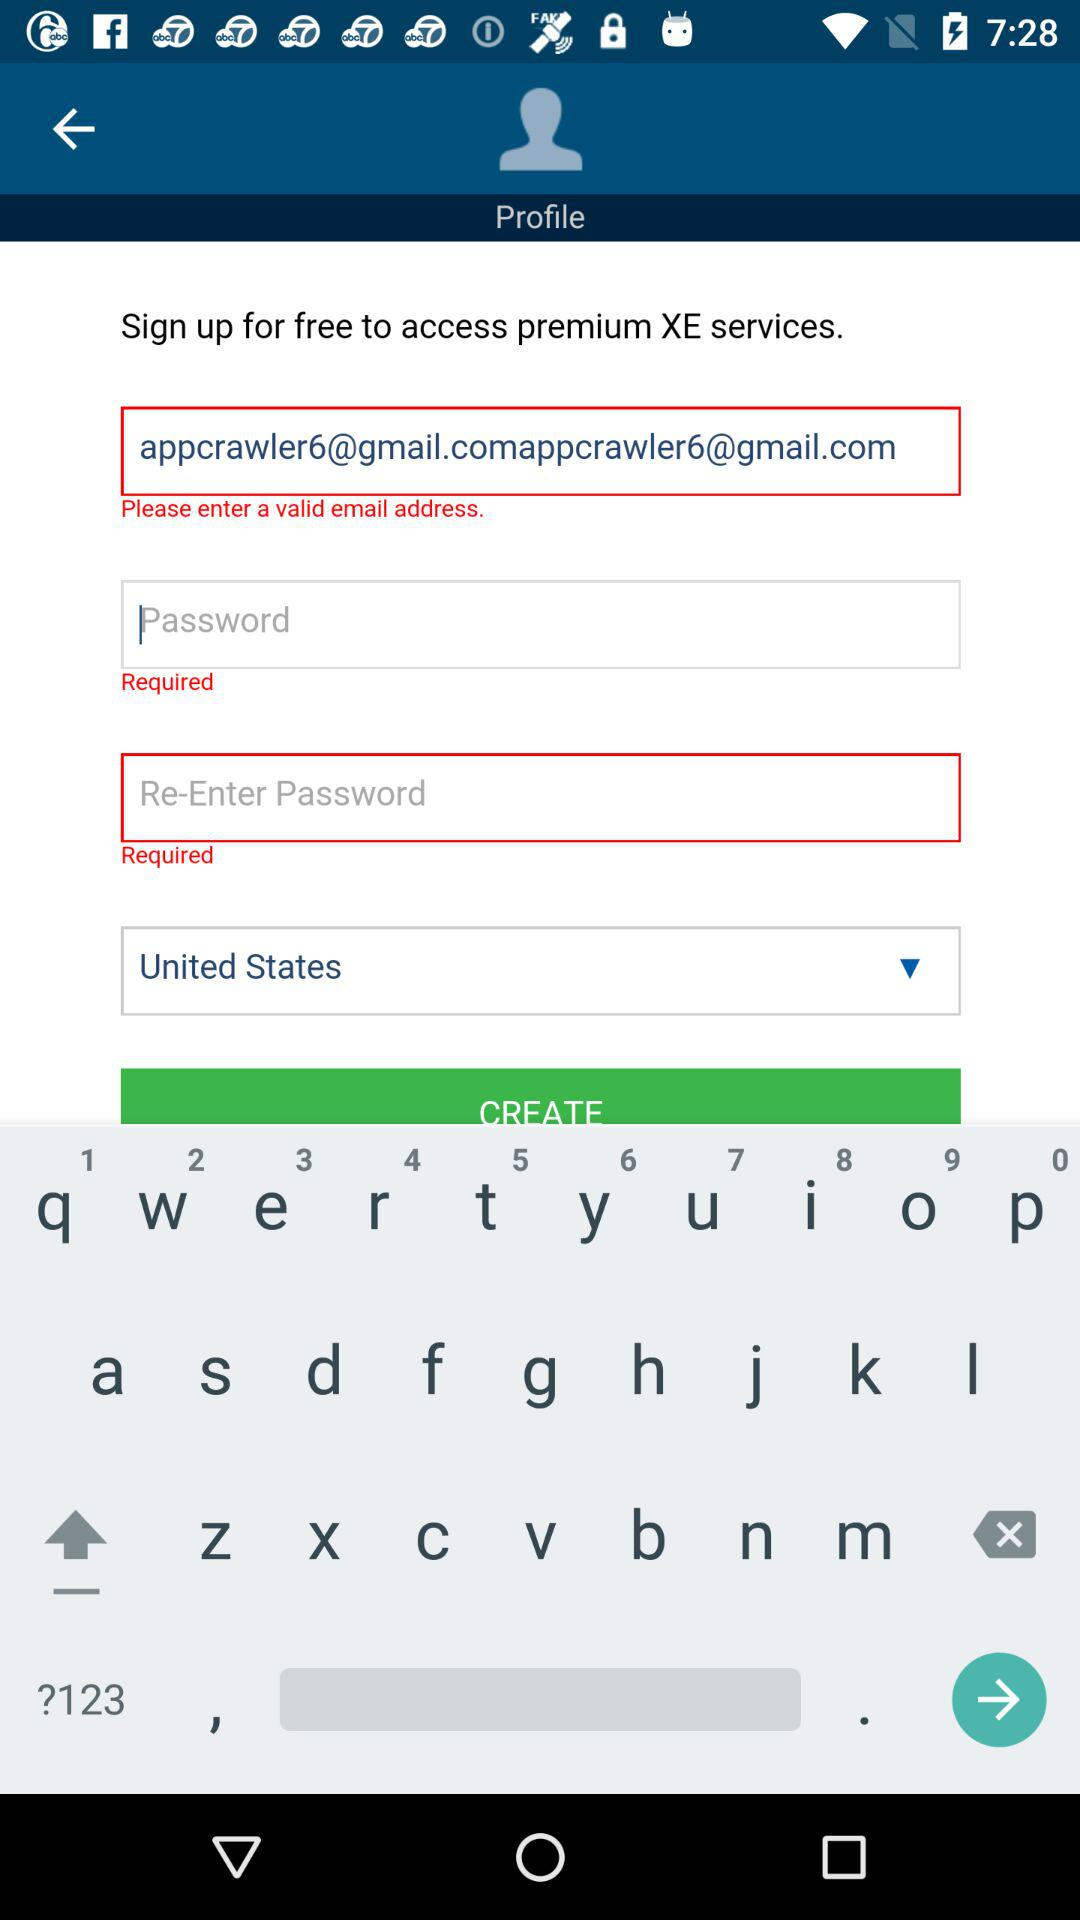How many required fields are there in the sign-up form?
Answer the question using a single word or phrase. 3 